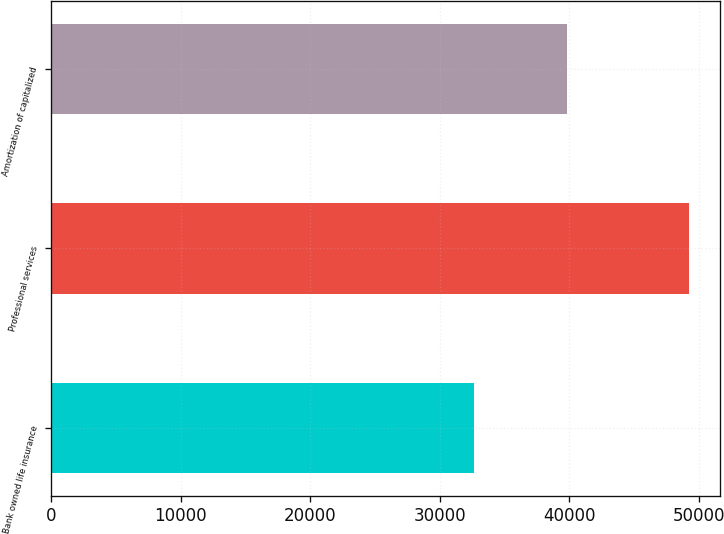<chart> <loc_0><loc_0><loc_500><loc_500><bar_chart><fcel>Bank owned life insurance<fcel>Professional services<fcel>Amortization of capitalized<nl><fcel>32625<fcel>49200<fcel>39806<nl></chart> 